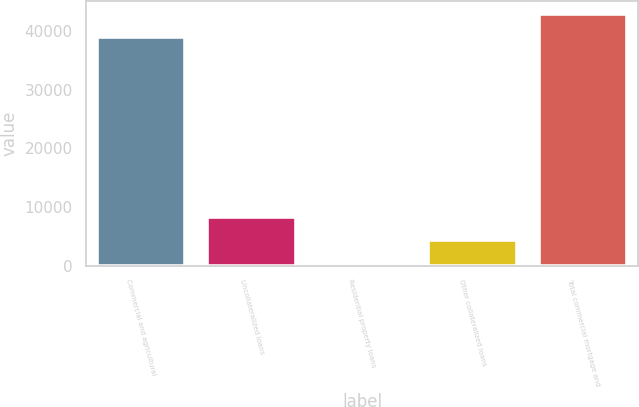Convert chart to OTSL. <chart><loc_0><loc_0><loc_500><loc_500><bar_chart><fcel>Commercial and agricultural<fcel>Uncollateralized loans<fcel>Residential property loans<fcel>Other collateralized loans<fcel>Total commercial mortgage and<nl><fcel>39002<fcel>8357<fcel>301<fcel>4329<fcel>43030<nl></chart> 